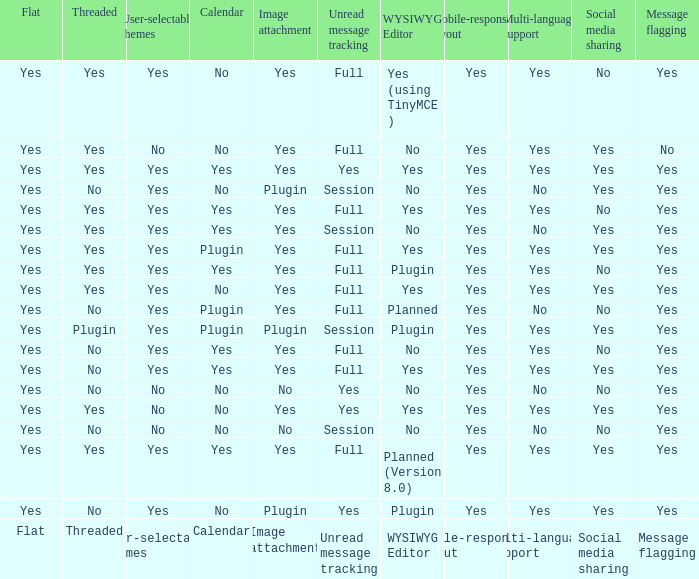Which wysiwyg editor comes with an image attachment feature and a calendar plugin? Yes, Planned. 